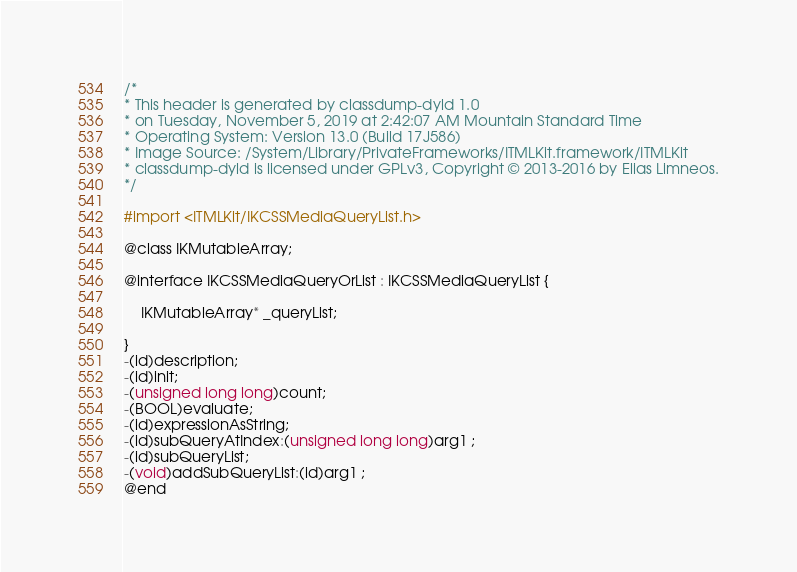Convert code to text. <code><loc_0><loc_0><loc_500><loc_500><_C_>/*
* This header is generated by classdump-dyld 1.0
* on Tuesday, November 5, 2019 at 2:42:07 AM Mountain Standard Time
* Operating System: Version 13.0 (Build 17J586)
* Image Source: /System/Library/PrivateFrameworks/ITMLKit.framework/ITMLKit
* classdump-dyld is licensed under GPLv3, Copyright © 2013-2016 by Elias Limneos.
*/

#import <ITMLKit/IKCSSMediaQueryList.h>

@class IKMutableArray;

@interface IKCSSMediaQueryOrList : IKCSSMediaQueryList {

	IKMutableArray* _queryList;

}
-(id)description;
-(id)init;
-(unsigned long long)count;
-(BOOL)evaluate;
-(id)expressionAsString;
-(id)subQueryAtIndex:(unsigned long long)arg1 ;
-(id)subQueryList;
-(void)addSubQueryList:(id)arg1 ;
@end

</code> 